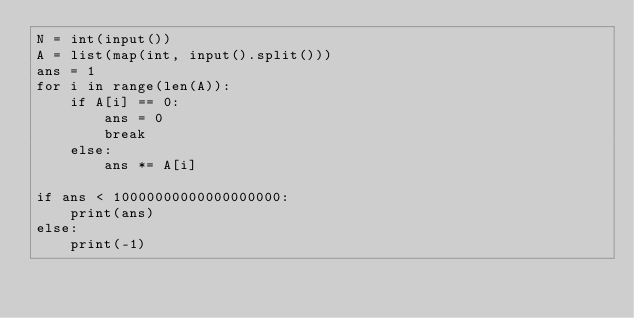Convert code to text. <code><loc_0><loc_0><loc_500><loc_500><_Python_>N = int(input())
A = list(map(int, input().split()))
ans = 1
for i in range(len(A)):
    if A[i] == 0:
        ans = 0
        break
    else:
        ans *= A[i]
  
if ans < 10000000000000000000:
    print(ans)
else:
    print(-1)</code> 